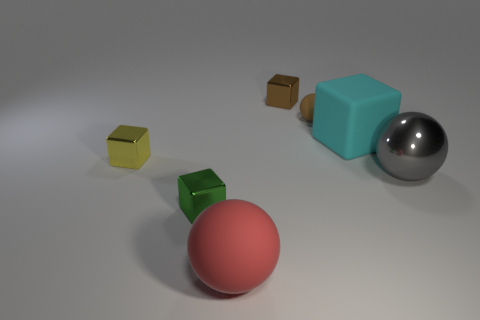There is a large sphere that is to the right of the large rubber thing that is in front of the big matte thing that is behind the tiny green thing; what is it made of? The large sphere to the right of the large rubber object, which in turn is in front of another big matte item and behind a tiny green object, appears to be made of a shiny metal, reflected in its highly reflective surface giving a mirror-like appearance. 